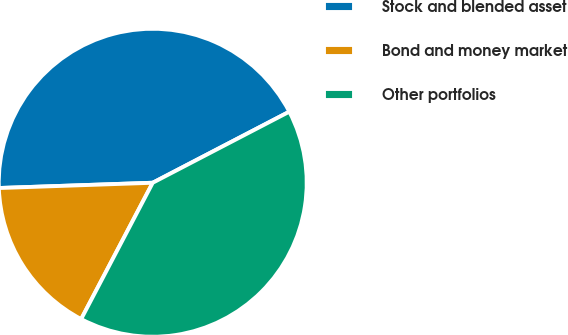Convert chart. <chart><loc_0><loc_0><loc_500><loc_500><pie_chart><fcel>Stock and blended asset<fcel>Bond and money market<fcel>Other portfolios<nl><fcel>42.91%<fcel>16.76%<fcel>40.33%<nl></chart> 